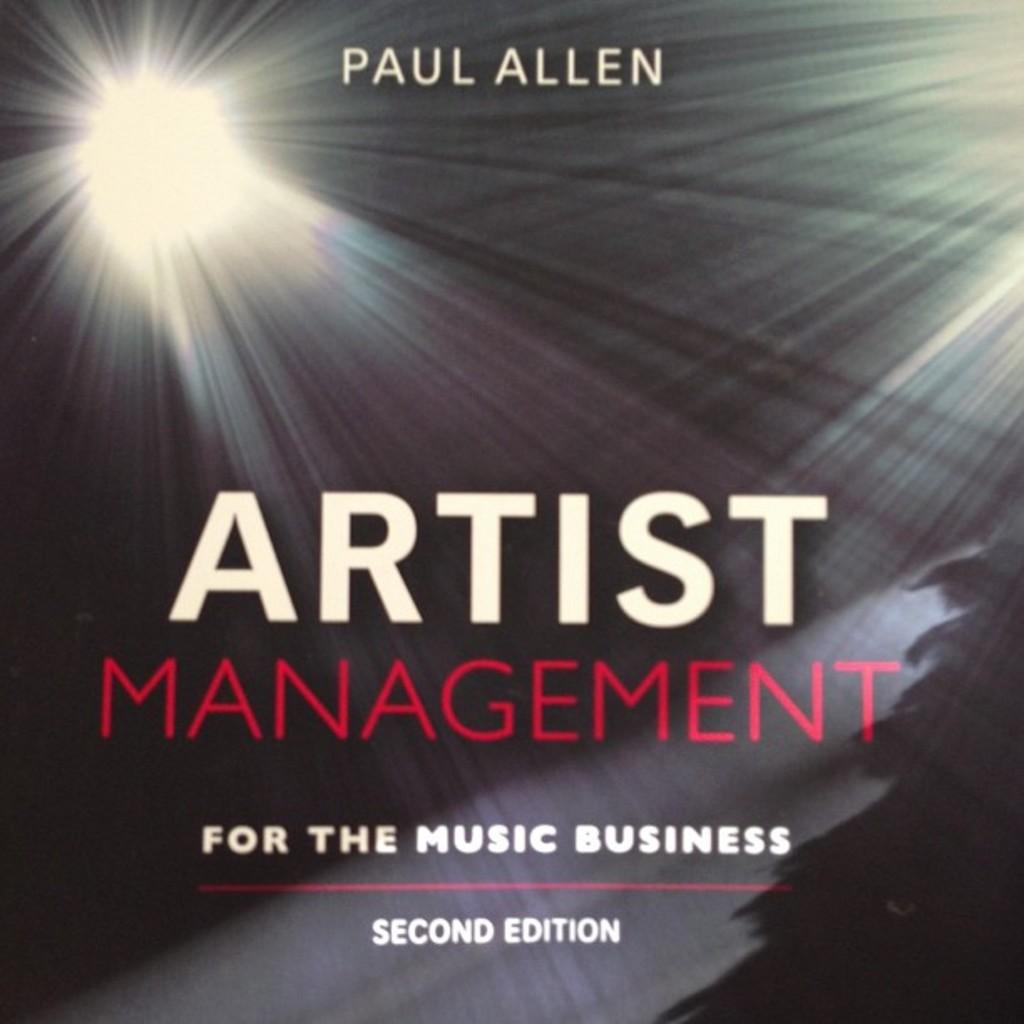<image>
Offer a succinct explanation of the picture presented. A second edition Artist management for the music business. 